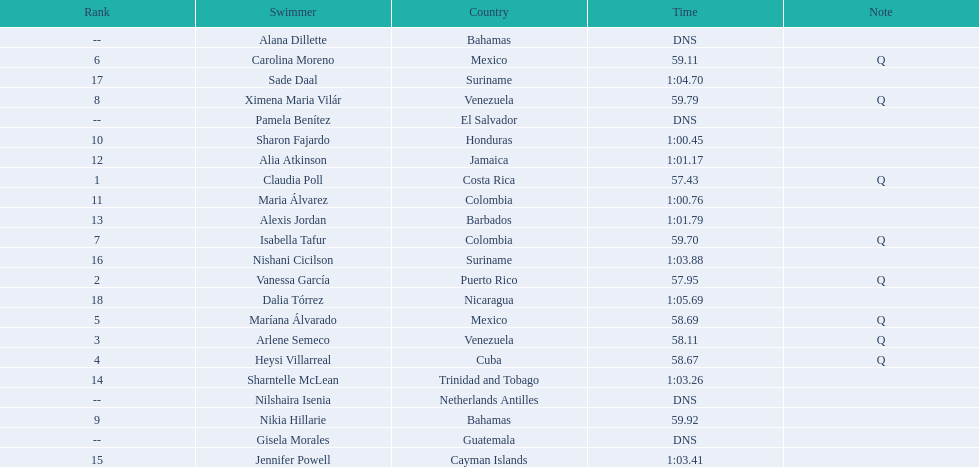Where were the top eight finishers from? Costa Rica, Puerto Rico, Venezuela, Cuba, Mexico, Mexico, Colombia, Venezuela. Which of the top eight were from cuba? Heysi Villarreal. 